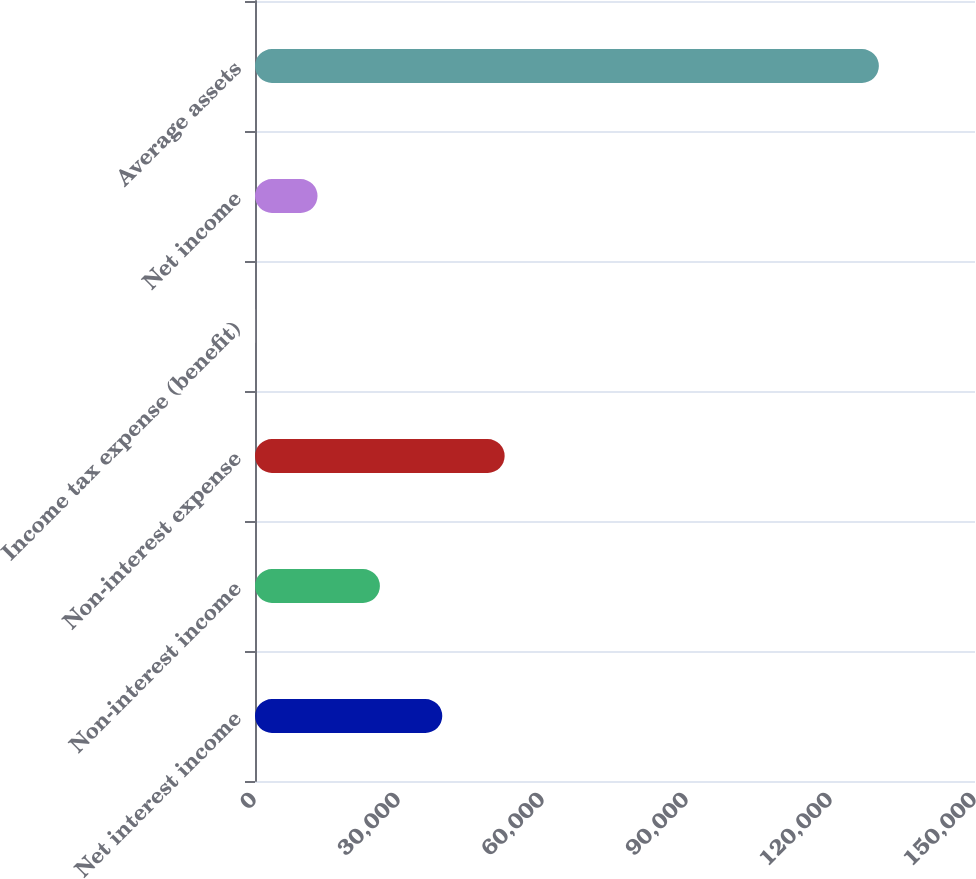Convert chart. <chart><loc_0><loc_0><loc_500><loc_500><bar_chart><fcel>Net interest income<fcel>Non-interest income<fcel>Non-interest expense<fcel>Income tax expense (benefit)<fcel>Net income<fcel>Average assets<nl><fcel>39014.3<fcel>26020.2<fcel>52008.4<fcel>32<fcel>13026.1<fcel>129973<nl></chart> 